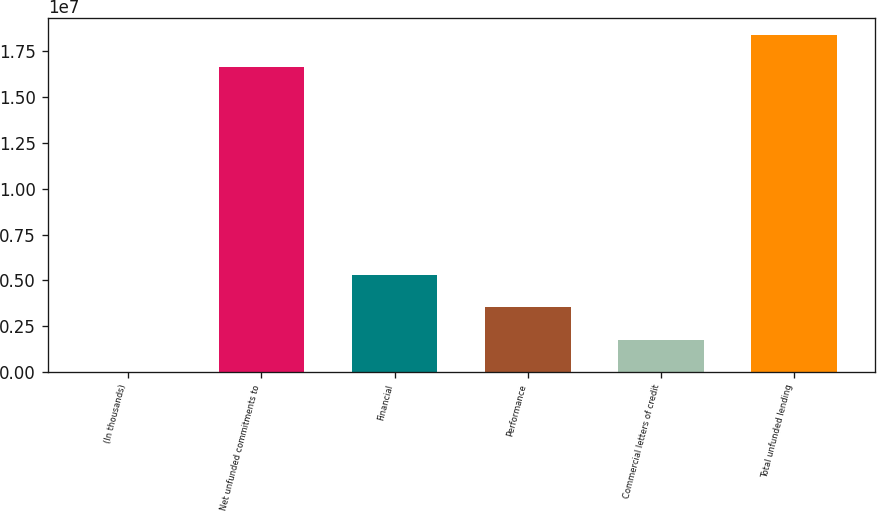Convert chart. <chart><loc_0><loc_0><loc_500><loc_500><bar_chart><fcel>(In thousands)<fcel>Net unfunded commitments to<fcel>Financial<fcel>Performance<fcel>Commercial letters of credit<fcel>Total unfunded lending<nl><fcel>2014<fcel>1.66588e+07<fcel>5.28749e+06<fcel>3.52567e+06<fcel>1.76384e+06<fcel>1.84206e+07<nl></chart> 